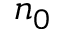<formula> <loc_0><loc_0><loc_500><loc_500>n _ { 0 }</formula> 